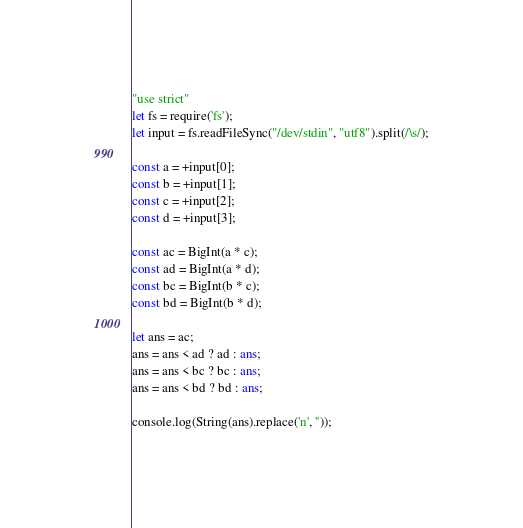Convert code to text. <code><loc_0><loc_0><loc_500><loc_500><_TypeScript_>"use strict"
let fs = require('fs');
let input = fs.readFileSync("/dev/stdin", "utf8").split(/\s/);
 
const a = +input[0];
const b = +input[1];
const c = +input[2];
const d = +input[3];
 
const ac = BigInt(a * c);
const ad = BigInt(a * d);
const bc = BigInt(b * c);
const bd = BigInt(b * d);
 
let ans = ac;
ans = ans < ad ? ad : ans;
ans = ans < bc ? bc : ans;
ans = ans < bd ? bd : ans;
 
console.log(String(ans).replace('n', ''));</code> 